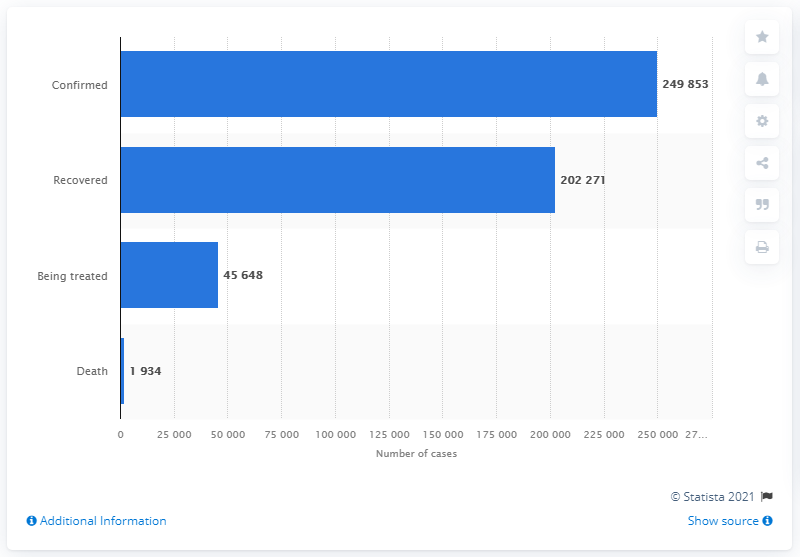List a handful of essential elements in this visual. As of June 28, 2021, a total of 249,853 new cases of COVID-19 were confirmed in Thailand. 